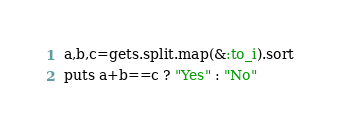Convert code to text. <code><loc_0><loc_0><loc_500><loc_500><_Ruby_>a,b,c=gets.split.map(&:to_i).sort
puts a+b==c ? "Yes" : "No"</code> 